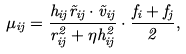<formula> <loc_0><loc_0><loc_500><loc_500>\mu _ { i j } = \frac { h _ { i j } \vec { r } _ { i j } \cdot \vec { v } _ { i j } } { r _ { i j } ^ { 2 } + \eta h _ { i j } ^ { 2 } } \cdot \frac { f _ { i } + f _ { j } } { 2 } ,</formula> 